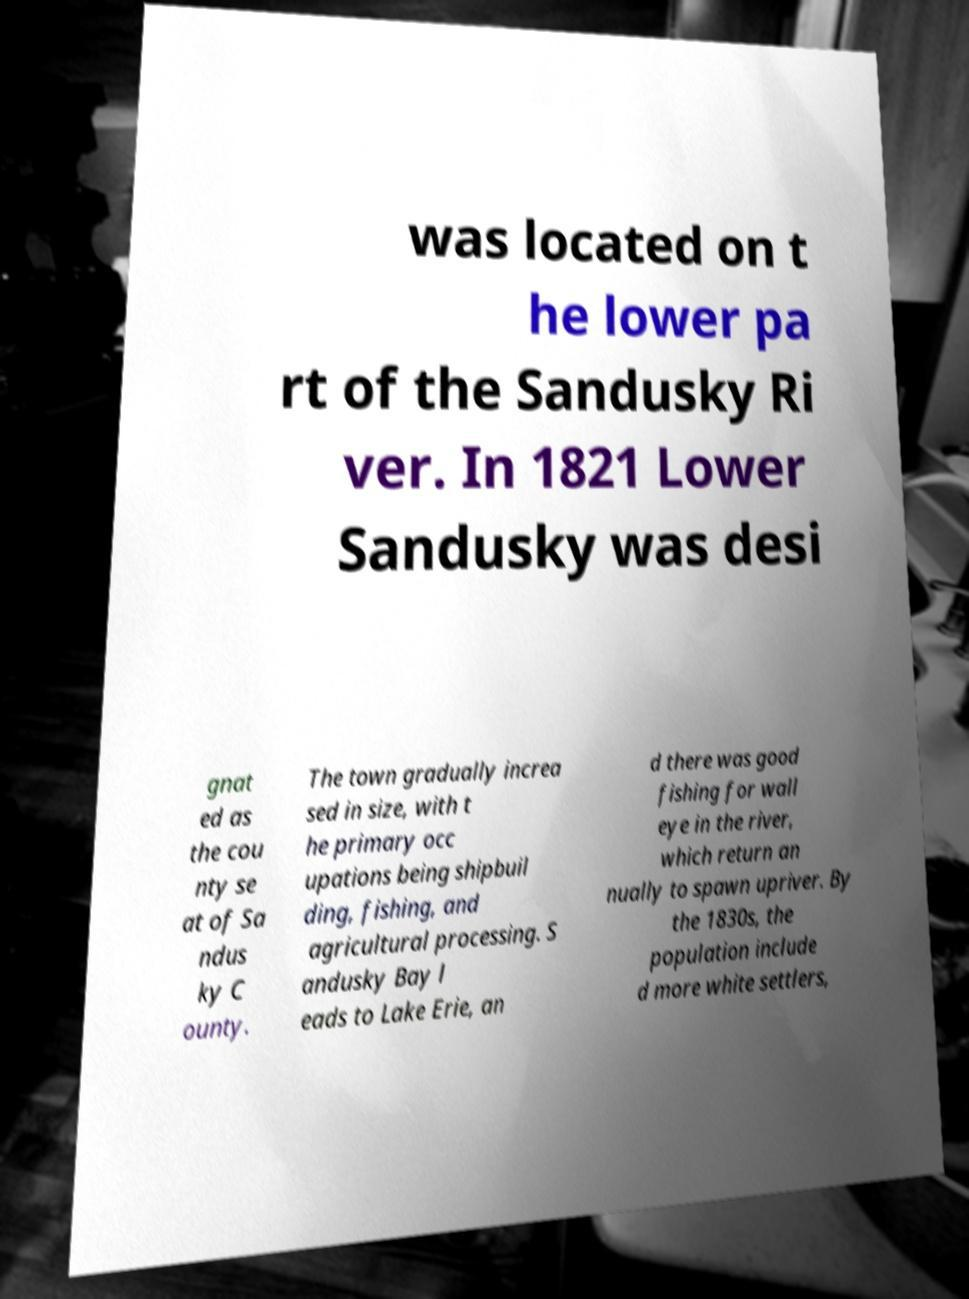There's text embedded in this image that I need extracted. Can you transcribe it verbatim? was located on t he lower pa rt of the Sandusky Ri ver. In 1821 Lower Sandusky was desi gnat ed as the cou nty se at of Sa ndus ky C ounty. The town gradually increa sed in size, with t he primary occ upations being shipbuil ding, fishing, and agricultural processing. S andusky Bay l eads to Lake Erie, an d there was good fishing for wall eye in the river, which return an nually to spawn upriver. By the 1830s, the population include d more white settlers, 